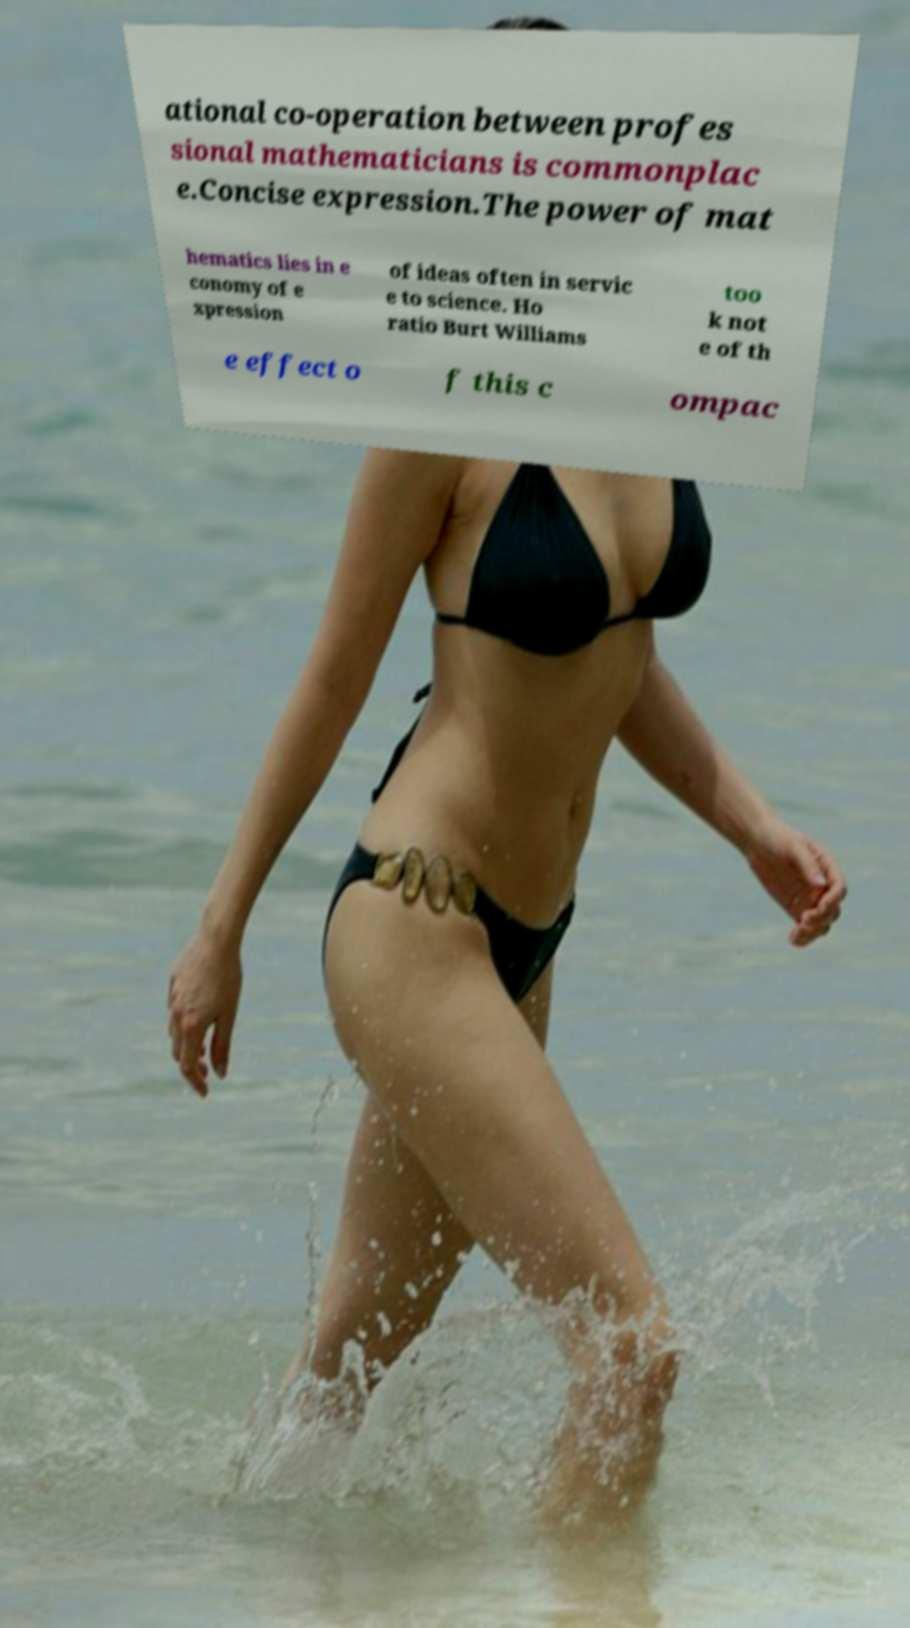Please read and relay the text visible in this image. What does it say? ational co-operation between profes sional mathematicians is commonplac e.Concise expression.The power of mat hematics lies in e conomy of e xpression of ideas often in servic e to science. Ho ratio Burt Williams too k not e of th e effect o f this c ompac 